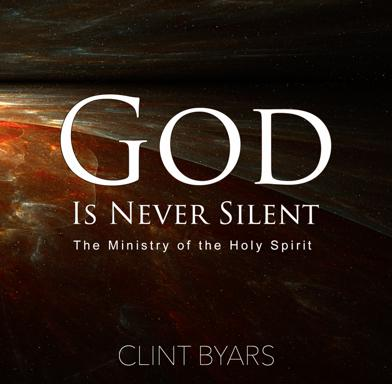How can the imagery used on the book cover of 'God Is Never Silent: The Ministry of the Holy Spirit' be interpreted in relation to its title? The book cover features a cosmic and somewhat ethereal visual, which could symbolize the omnipresence and omnipotence of God. The swirling patterns and dark backdrop might represent the mysterious and all-encompassing nature of the Holy Spirit, suggesting that God's communication and guidance are as vast and profound as the universe. 